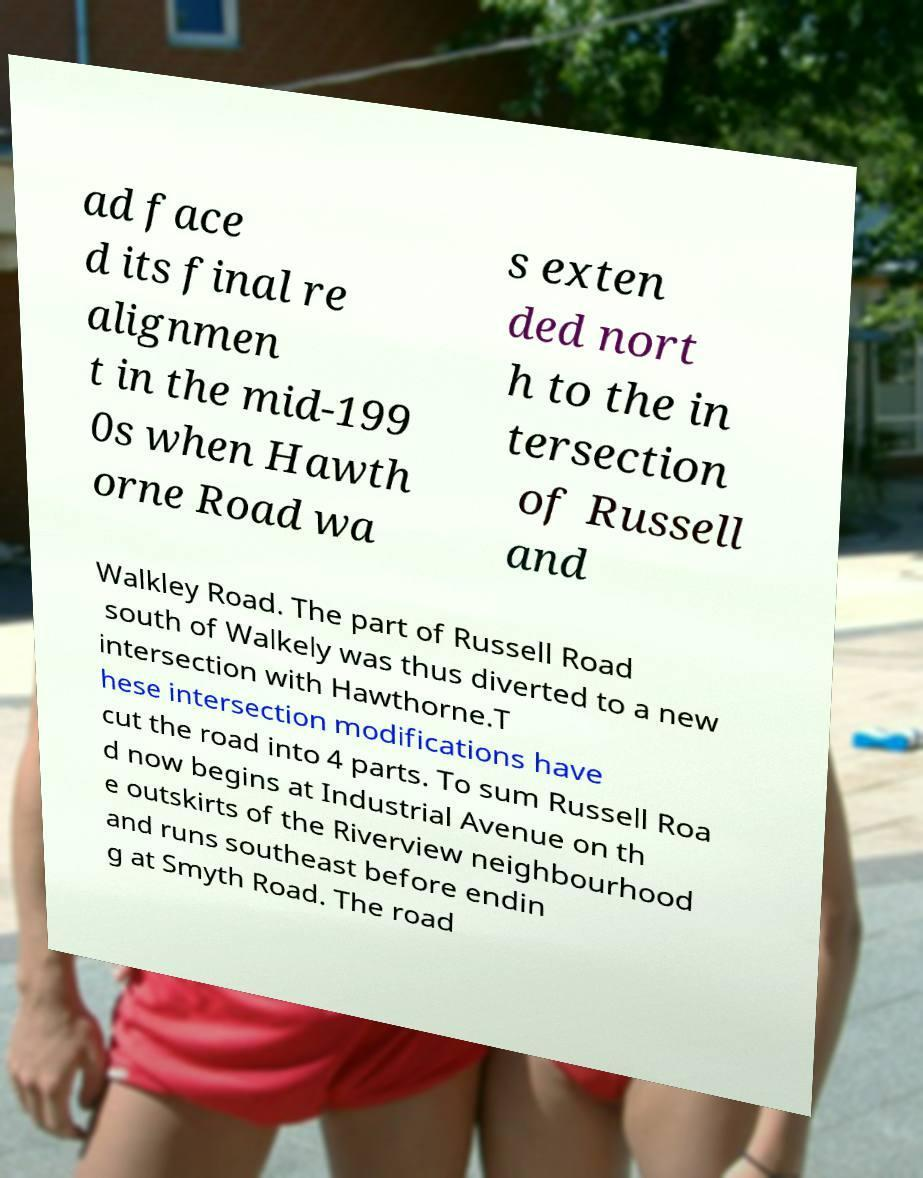Please identify and transcribe the text found in this image. ad face d its final re alignmen t in the mid-199 0s when Hawth orne Road wa s exten ded nort h to the in tersection of Russell and Walkley Road. The part of Russell Road south of Walkely was thus diverted to a new intersection with Hawthorne.T hese intersection modifications have cut the road into 4 parts. To sum Russell Roa d now begins at Industrial Avenue on th e outskirts of the Riverview neighbourhood and runs southeast before endin g at Smyth Road. The road 